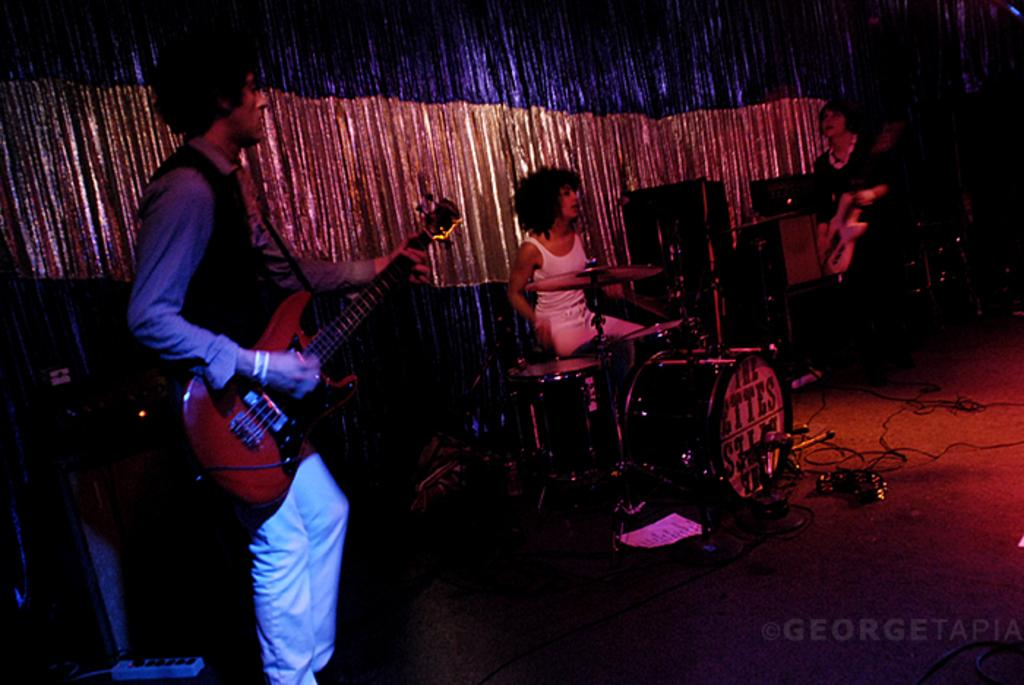What is the man in the image doing? The man is standing and playing a guitar in the image. What is the seated woman in the image doing? The seated woman is playing drums in the image. How many women are present in the image? There are two women present in the image. What are the women holding in their hands? One woman is holding a guitar in her hand. What type of animal can be seen playing the guitar in the image? There are no animals present in the image, and therefore no animal is playing the guitar. Can you tell me how many bottles are visible in the image? There is no mention of bottles in the provided facts, and therefore we cannot determine if any bottles are visible in the image. 